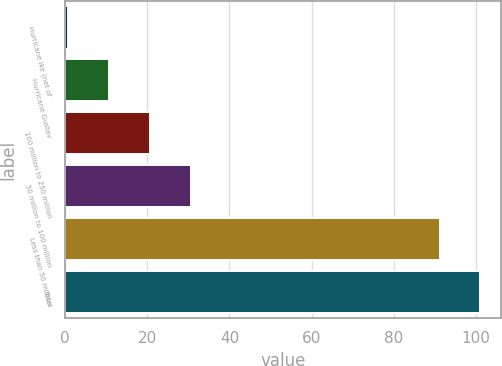<chart> <loc_0><loc_0><loc_500><loc_500><bar_chart><fcel>Hurricane Ike (net of<fcel>Hurricane Gustav<fcel>100 million to 250 million<fcel>50 million to 100 million<fcel>Less than 50 million<fcel>Total<nl><fcel>0.8<fcel>10.72<fcel>20.64<fcel>30.56<fcel>91.1<fcel>101.02<nl></chart> 